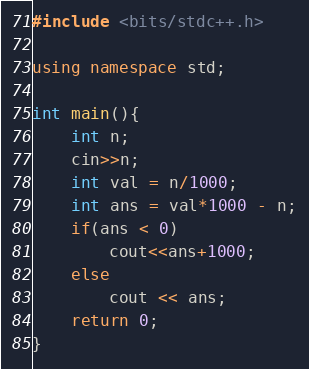Convert code to text. <code><loc_0><loc_0><loc_500><loc_500><_C++_>#include <bits/stdc++.h>

using namespace std;

int main(){
    int n;
    cin>>n;
    int val = n/1000;
    int ans = val*1000 - n;
    if(ans < 0)
        cout<<ans+1000;
    else
        cout << ans;
    return 0; 
}</code> 